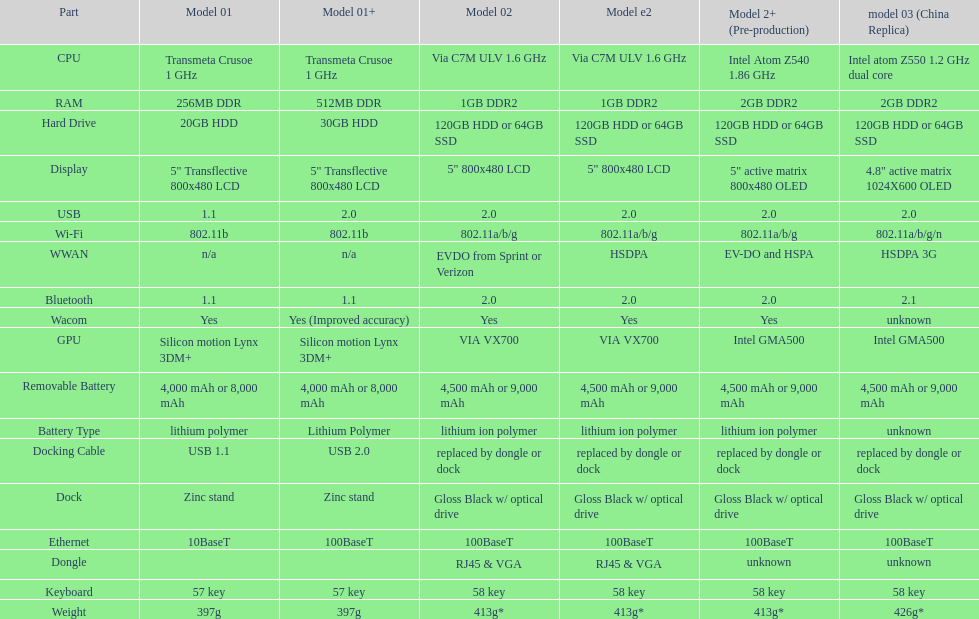Are there at least 13 different components on the chart? Yes. 